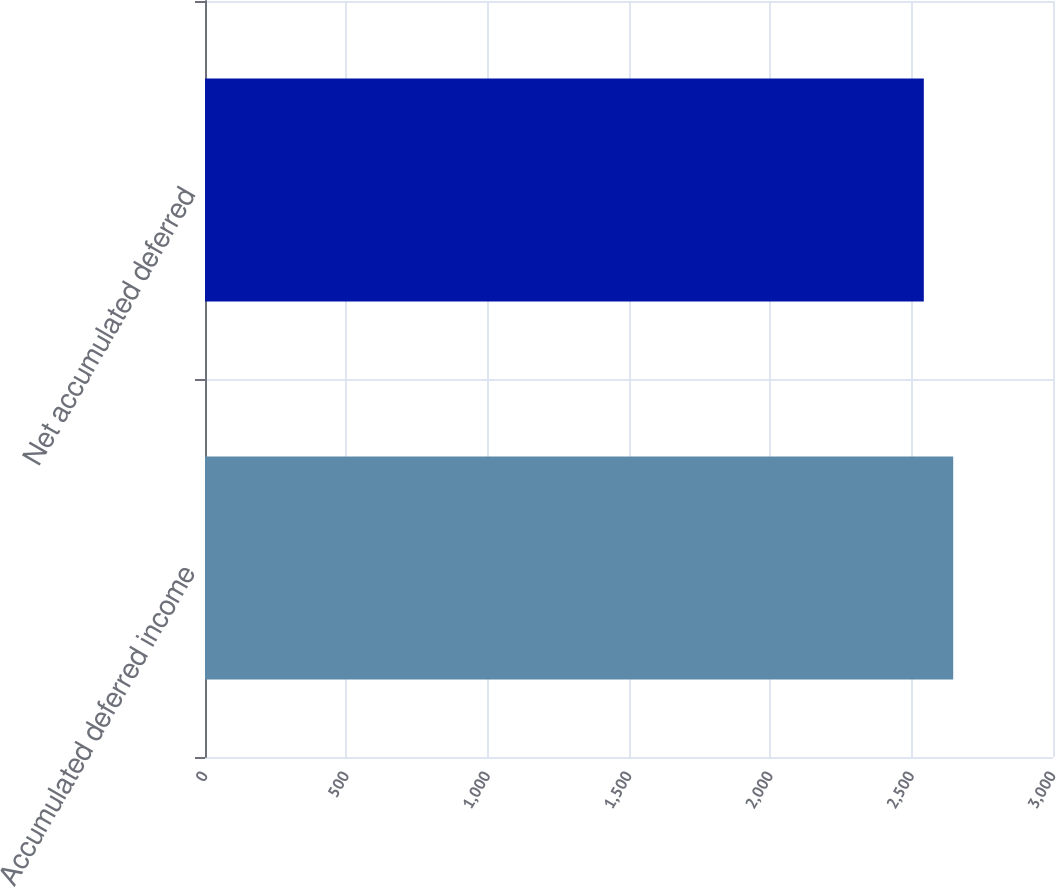<chart> <loc_0><loc_0><loc_500><loc_500><bar_chart><fcel>Accumulated deferred income<fcel>Net accumulated deferred<nl><fcel>2647<fcel>2543<nl></chart> 